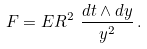Convert formula to latex. <formula><loc_0><loc_0><loc_500><loc_500>F = E R ^ { 2 } \ \frac { d t \wedge d y } { y ^ { 2 } } \, .</formula> 